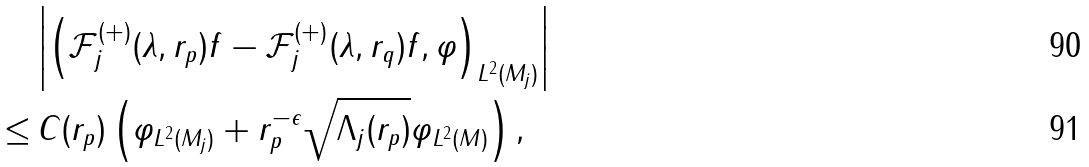<formula> <loc_0><loc_0><loc_500><loc_500>& \left | \left ( \mathcal { F } _ { j } ^ { ( + ) } ( \lambda , r _ { p } ) f - \mathcal { F } _ { j } ^ { ( + ) } ( \lambda , r _ { q } ) f , \varphi \right ) _ { L ^ { 2 } ( M _ { j } ) } \right | \\ \leq & \, C ( r _ { p } ) \left ( \| \varphi \| _ { L ^ { 2 } ( M _ { j } ) } + r _ { p } ^ { - \epsilon } \| \sqrt { \Lambda _ { j } ( r _ { p } ) } \varphi \| _ { L ^ { 2 } ( M ) } \right ) ,</formula> 